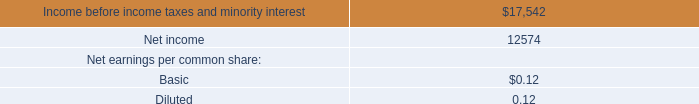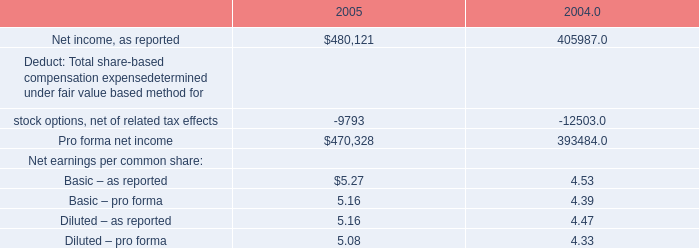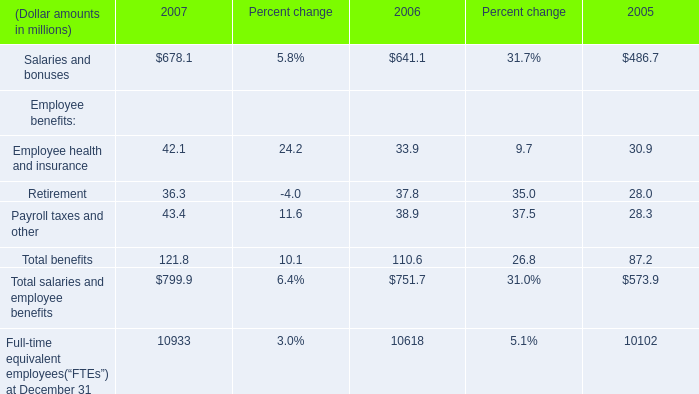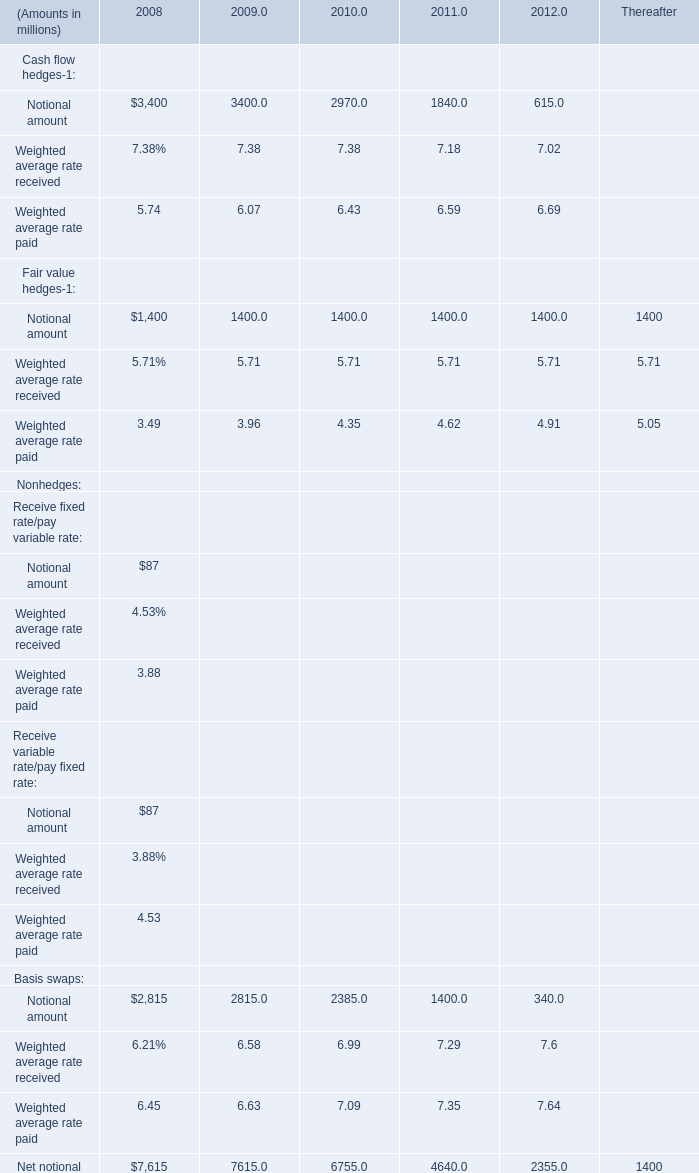What was the total amount of 2010 greater than 0 in 2008 for Nonhedges for Amount? (in million) 
Computations: (((87 + 87) + 2815) + 7615)
Answer: 10604.0. 